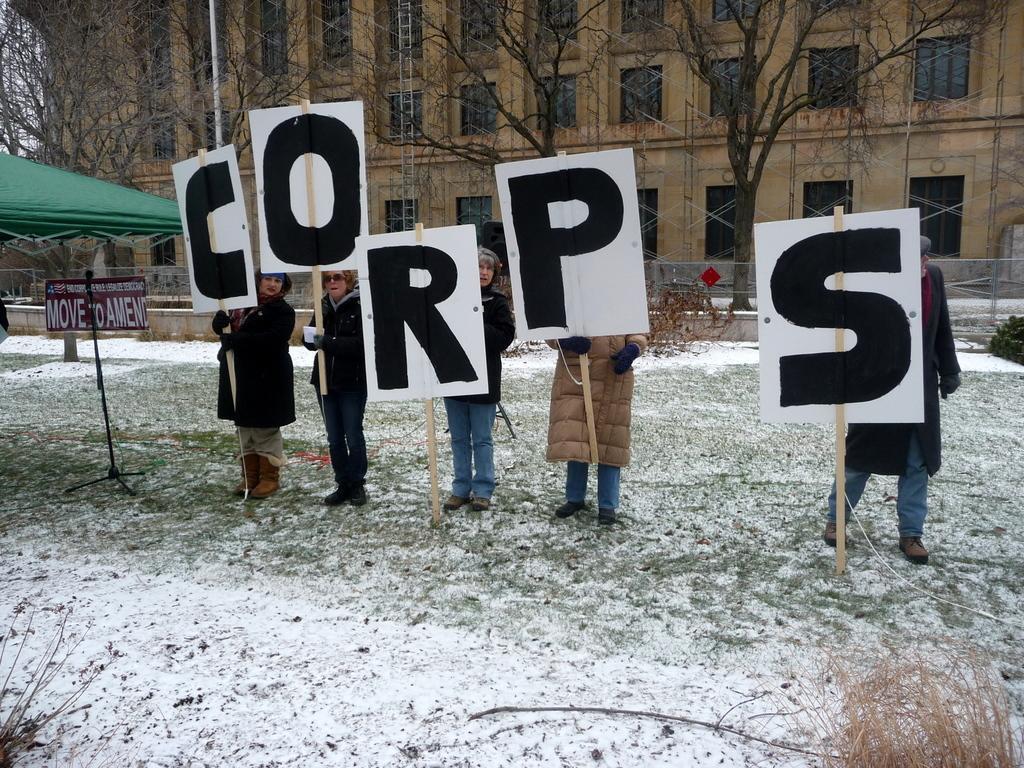Can you describe this image briefly? In this image we can see few persons are standing on the ground and holding boards in their hands. On the left side we can see a tent, board on a pole. In the background there are trees, pole, ladder, building, windows, sky and other objects. 